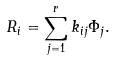Convert formula to latex. <formula><loc_0><loc_0><loc_500><loc_500>R _ { i } = \sum _ { j = 1 } ^ { r } k _ { i j } \Phi _ { j } .</formula> 